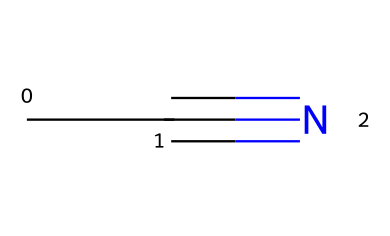What is the molecular formula of acetonitrile? The chemical structure shown corresponds to acetonitrile, which has a carbon atom bonded to another carbon and a nitrogen atom triple-bonded to it. Therefore, the molecular formula is derived from the count of carbon (C) and nitrogen (N) atoms, which gives us C2H3N.
Answer: C2H3N How many carbon atoms are present in acetonitrile? By analyzing the structure, we can observe that there are two carbon atoms in the acetonitrile molecule (the CC part of the SMILES).
Answer: 2 What type of functional group is present in acetonitrile? Acetonitrile contains a nitrile group, which is characterized by a carbon atom triple-bonded to a nitrogen atom. This is evident from the #N in the SMILES, indicating the presence of the nitrile functional group.
Answer: nitrile What is the total number of bonds in acetonitrile? In the structure, there are three types of bonds: a single bond between two carbon atoms, and a triple bond between one of the carbon atoms and the nitrogen atom. This leads to a total of four bonds: one single bond and one triple bond (counted as three).
Answer: 4 What is the primary use of acetonitrile in laboratory settings? Acetonitrile is primarily used as a solvent in high-performance liquid chromatography (HPLC). This usage is due to its properties, such as low viscosity and the ability to dissolve various substances effectively, making it suitable for document preservation applications.
Answer: solvent in HPLC Is acetonitrile polar or non-polar? Acetonitrile is polar, primarily due to the electronegativity difference between carbon and nitrogen, which creates a dipole moment in the molecule. This polarity contributes to its solubility characteristics as well.
Answer: polar 